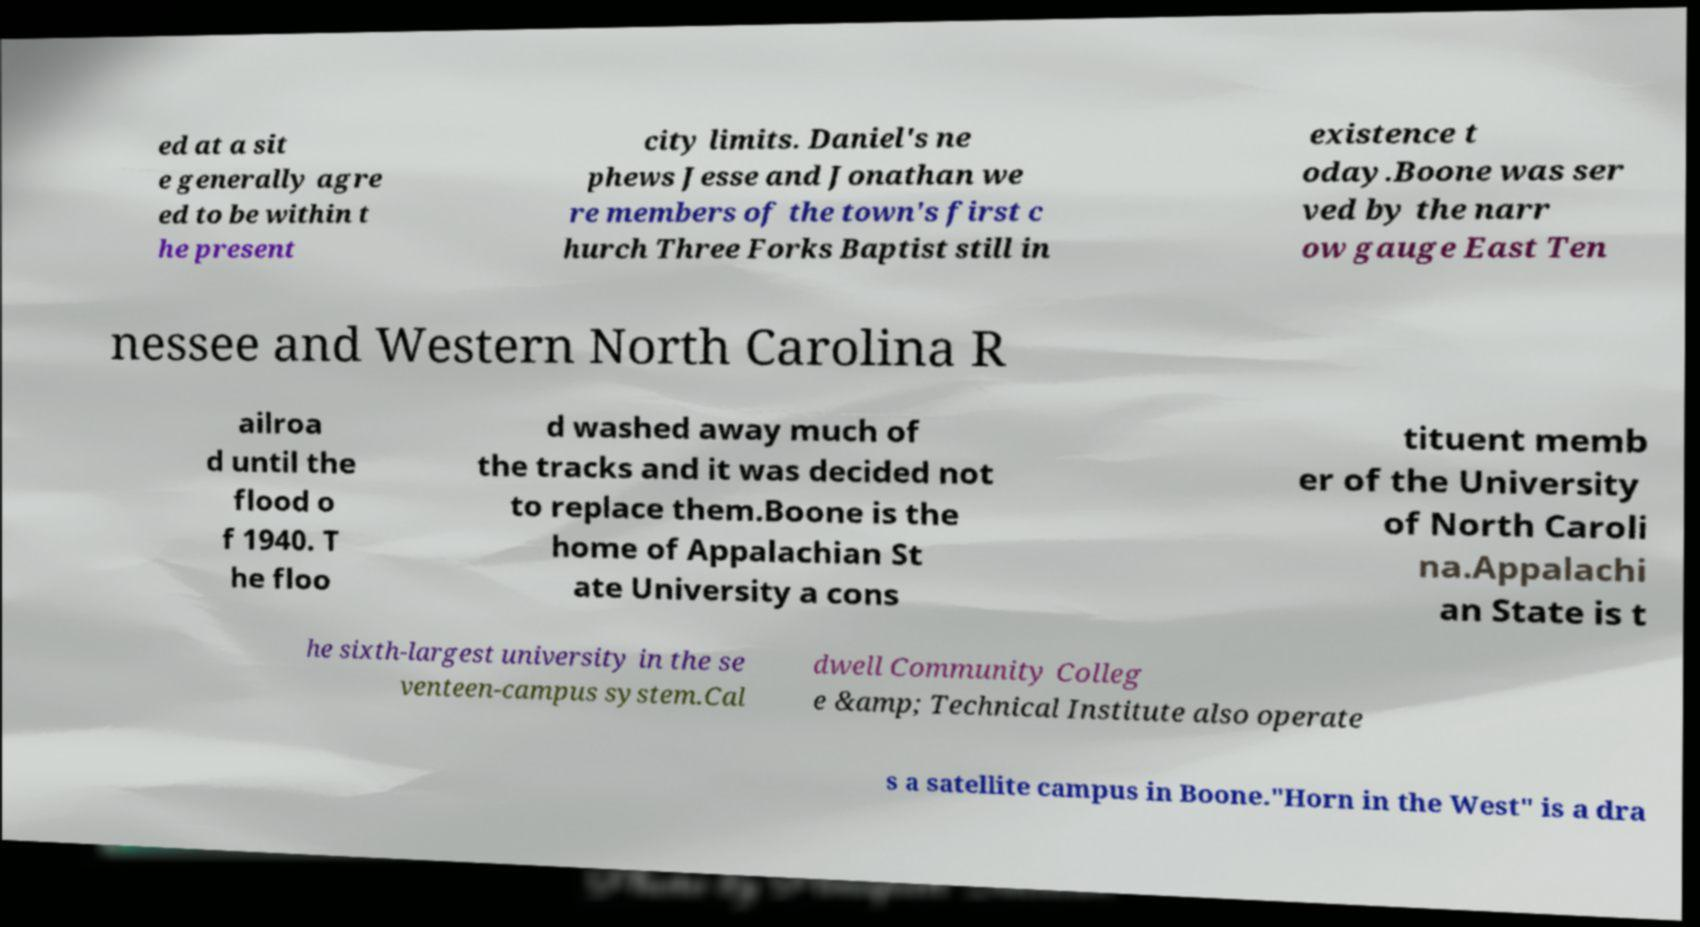Please read and relay the text visible in this image. What does it say? ed at a sit e generally agre ed to be within t he present city limits. Daniel's ne phews Jesse and Jonathan we re members of the town's first c hurch Three Forks Baptist still in existence t oday.Boone was ser ved by the narr ow gauge East Ten nessee and Western North Carolina R ailroa d until the flood o f 1940. T he floo d washed away much of the tracks and it was decided not to replace them.Boone is the home of Appalachian St ate University a cons tituent memb er of the University of North Caroli na.Appalachi an State is t he sixth-largest university in the se venteen-campus system.Cal dwell Community Colleg e &amp; Technical Institute also operate s a satellite campus in Boone."Horn in the West" is a dra 